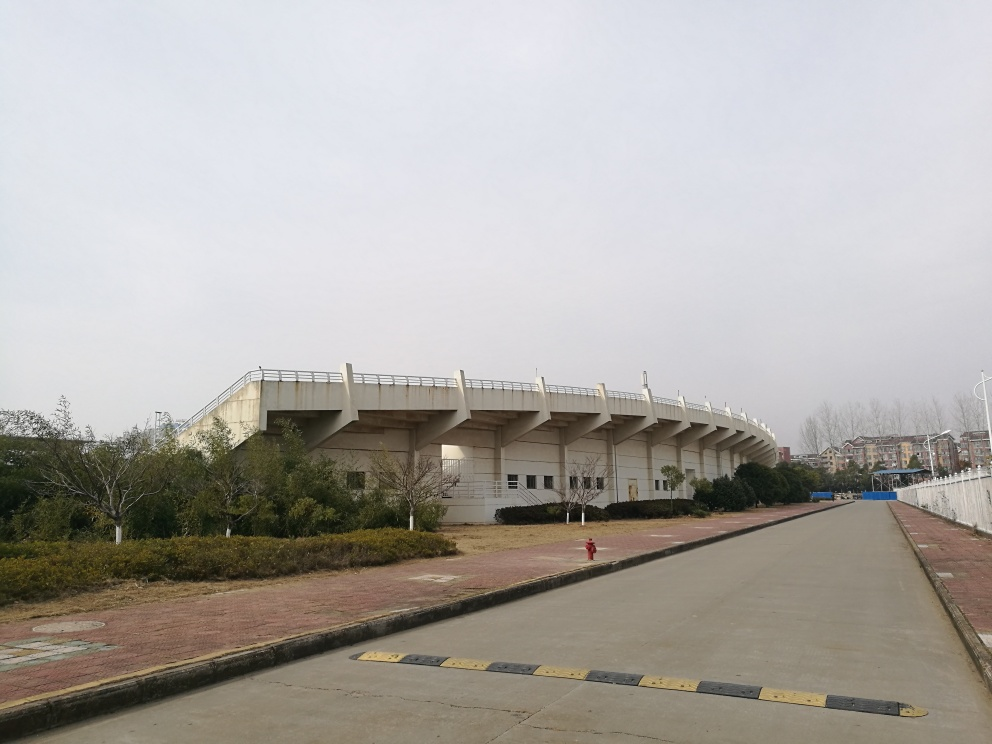What architectural style or period does the building in the image represent? The building depicted in the image seems to embody a modernist architectural style, characterized by its minimalist facade, functional form, and use of concrete. The design likely originates from the late 20th to early 21st century, a period favoring simplicity and practicality over decorative elements. What might be the purpose of this building? Judging by the sloped sides and the overall design, the structure could serve as a sports venue, possibly a stadium or arena. Its size and open surroundings suggest that it is meant to accommodate a large number of visitors for events such as sports competitions or concerts. 